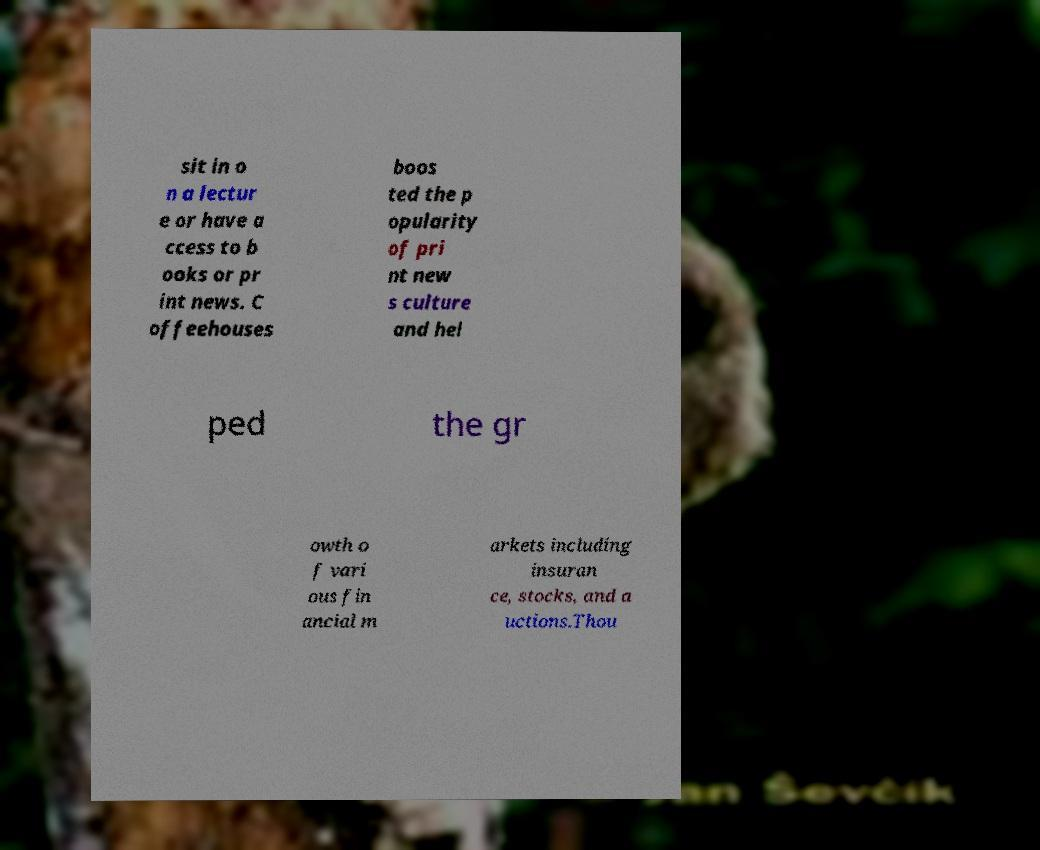Can you read and provide the text displayed in the image?This photo seems to have some interesting text. Can you extract and type it out for me? sit in o n a lectur e or have a ccess to b ooks or pr int news. C offeehouses boos ted the p opularity of pri nt new s culture and hel ped the gr owth o f vari ous fin ancial m arkets including insuran ce, stocks, and a uctions.Thou 